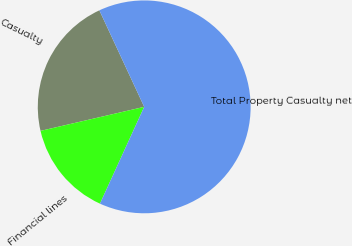<chart> <loc_0><loc_0><loc_500><loc_500><pie_chart><fcel>Casualty<fcel>Financial lines<fcel>Total Property Casualty net<nl><fcel>21.7%<fcel>14.55%<fcel>63.74%<nl></chart> 